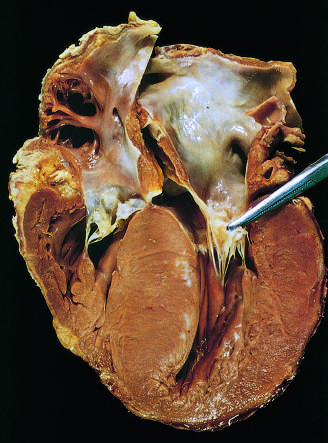what is enlarged?
Answer the question using a single word or phrase. The left atrium 